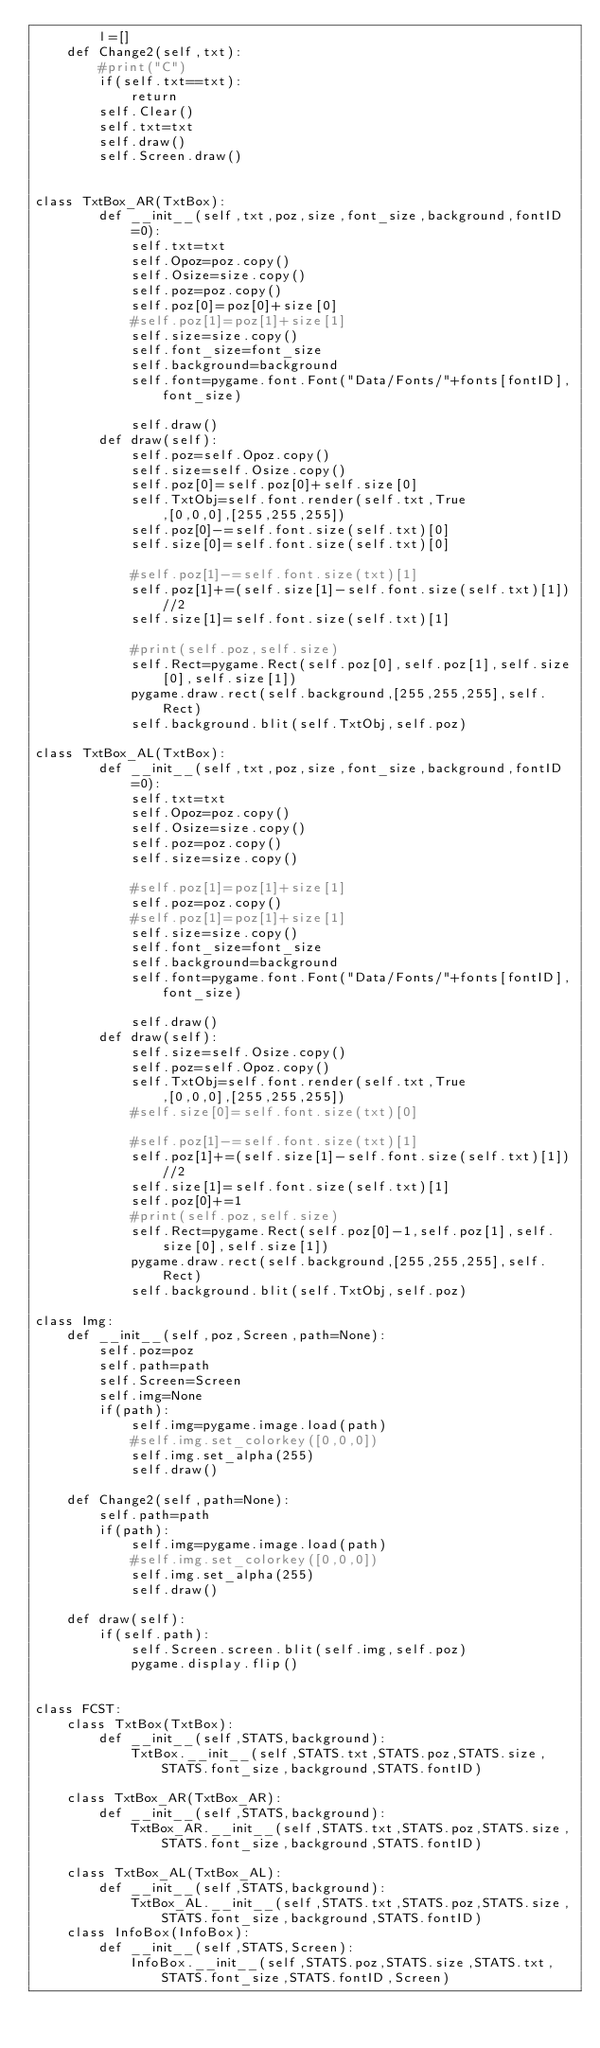<code> <loc_0><loc_0><loc_500><loc_500><_Python_>        l=[]
    def Change2(self,txt):
        #print("C")
        if(self.txt==txt):
            return
        self.Clear()
        self.txt=txt
        self.draw()
        self.Screen.draw()


class TxtBox_AR(TxtBox):
        def __init__(self,txt,poz,size,font_size,background,fontID=0):
            self.txt=txt
            self.Opoz=poz.copy()
            self.Osize=size.copy()
            self.poz=poz.copy()
            self.poz[0]=poz[0]+size[0]
            #self.poz[1]=poz[1]+size[1]
            self.size=size.copy()
            self.font_size=font_size
            self.background=background
            self.font=pygame.font.Font("Data/Fonts/"+fonts[fontID],font_size)

            self.draw()
        def draw(self):
            self.poz=self.Opoz.copy()
            self.size=self.Osize.copy()
            self.poz[0]=self.poz[0]+self.size[0]
            self.TxtObj=self.font.render(self.txt,True,[0,0,0],[255,255,255])
            self.poz[0]-=self.font.size(self.txt)[0]
            self.size[0]=self.font.size(self.txt)[0]

            #self.poz[1]-=self.font.size(txt)[1]
            self.poz[1]+=(self.size[1]-self.font.size(self.txt)[1])//2
            self.size[1]=self.font.size(self.txt)[1]

            #print(self.poz,self.size)
            self.Rect=pygame.Rect(self.poz[0],self.poz[1],self.size[0],self.size[1])
            pygame.draw.rect(self.background,[255,255,255],self.Rect)
            self.background.blit(self.TxtObj,self.poz)

class TxtBox_AL(TxtBox):
        def __init__(self,txt,poz,size,font_size,background,fontID=0):
            self.txt=txt
            self.Opoz=poz.copy()
            self.Osize=size.copy()
            self.poz=poz.copy()
            self.size=size.copy()

            #self.poz[1]=poz[1]+size[1]
            self.poz=poz.copy()
            #self.poz[1]=poz[1]+size[1]
            self.size=size.copy()
            self.font_size=font_size
            self.background=background
            self.font=pygame.font.Font("Data/Fonts/"+fonts[fontID],font_size)

            self.draw()
        def draw(self):
            self.size=self.Osize.copy()
            self.poz=self.Opoz.copy()
            self.TxtObj=self.font.render(self.txt,True,[0,0,0],[255,255,255])
            #self.size[0]=self.font.size(txt)[0]

            #self.poz[1]-=self.font.size(txt)[1]
            self.poz[1]+=(self.size[1]-self.font.size(self.txt)[1])//2
            self.size[1]=self.font.size(self.txt)[1]
            self.poz[0]+=1
            #print(self.poz,self.size)
            self.Rect=pygame.Rect(self.poz[0]-1,self.poz[1],self.size[0],self.size[1])
            pygame.draw.rect(self.background,[255,255,255],self.Rect)
            self.background.blit(self.TxtObj,self.poz)

class Img:
    def __init__(self,poz,Screen,path=None):
        self.poz=poz
        self.path=path
        self.Screen=Screen
        self.img=None
        if(path):
            self.img=pygame.image.load(path)
            #self.img.set_colorkey([0,0,0])
            self.img.set_alpha(255)
            self.draw()

    def Change2(self,path=None):
        self.path=path
        if(path):
            self.img=pygame.image.load(path)
            #self.img.set_colorkey([0,0,0])
            self.img.set_alpha(255)
            self.draw()

    def draw(self):
        if(self.path):
            self.Screen.screen.blit(self.img,self.poz)
            pygame.display.flip()


class FCST:
    class TxtBox(TxtBox):
        def __init__(self,STATS,background):
            TxtBox.__init__(self,STATS.txt,STATS.poz,STATS.size,STATS.font_size,background,STATS.fontID)

    class TxtBox_AR(TxtBox_AR):
        def __init__(self,STATS,background):
            TxtBox_AR.__init__(self,STATS.txt,STATS.poz,STATS.size,STATS.font_size,background,STATS.fontID)

    class TxtBox_AL(TxtBox_AL):
        def __init__(self,STATS,background):
            TxtBox_AL.__init__(self,STATS.txt,STATS.poz,STATS.size,STATS.font_size,background,STATS.fontID)
    class InfoBox(InfoBox):
        def __init__(self,STATS,Screen):
            InfoBox.__init__(self,STATS.poz,STATS.size,STATS.txt,STATS.font_size,STATS.fontID,Screen)
</code> 